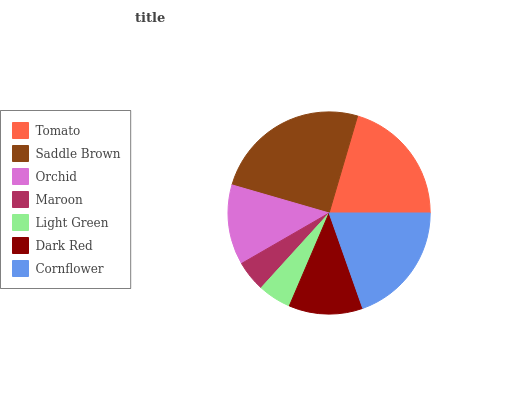Is Maroon the minimum?
Answer yes or no. Yes. Is Saddle Brown the maximum?
Answer yes or no. Yes. Is Orchid the minimum?
Answer yes or no. No. Is Orchid the maximum?
Answer yes or no. No. Is Saddle Brown greater than Orchid?
Answer yes or no. Yes. Is Orchid less than Saddle Brown?
Answer yes or no. Yes. Is Orchid greater than Saddle Brown?
Answer yes or no. No. Is Saddle Brown less than Orchid?
Answer yes or no. No. Is Orchid the high median?
Answer yes or no. Yes. Is Orchid the low median?
Answer yes or no. Yes. Is Light Green the high median?
Answer yes or no. No. Is Saddle Brown the low median?
Answer yes or no. No. 